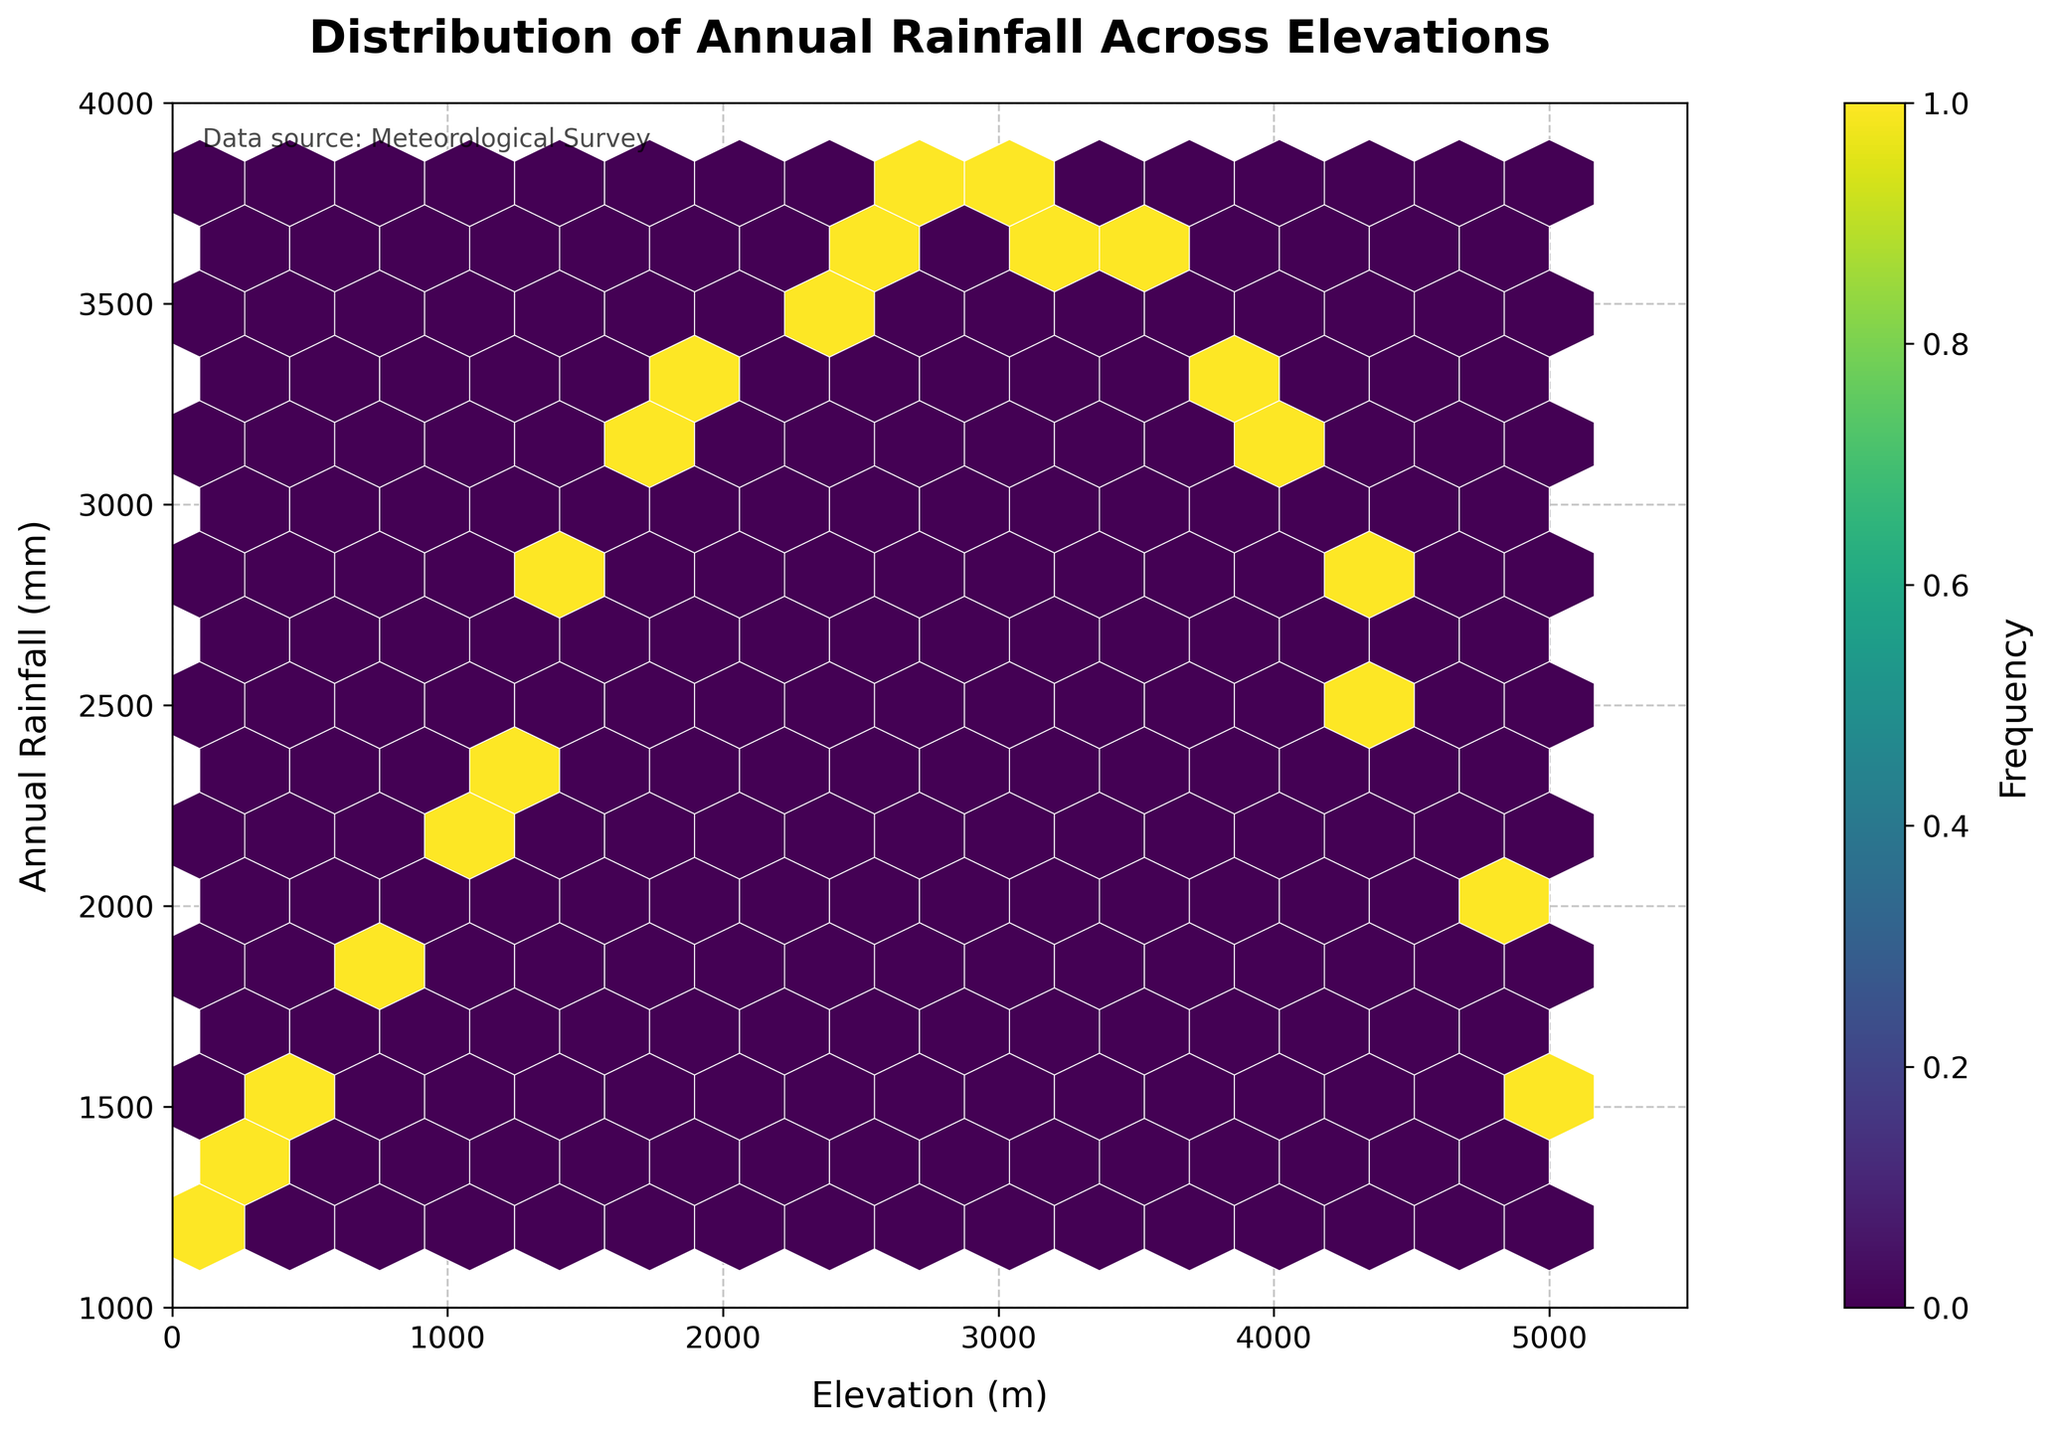What does the title of the hexbin plot indicate? The title of the hexbin plot is "Distribution of Annual Rainfall Across Elevations", which indicates that the plot shows how annual rainfall varies with elevation in a mountainous region.
Answer: Distribution of Annual Rainfall Across Elevations What is the range of elevations covered in the plot? The x-axis of the plot ranges from 0 to 5500 meters, indicating that the elevations covered in the plot are between 0 and 5500 meters.
Answer: 0 to 5500 meters Which frequency color is used to represent the highest density of data points? The plot uses the 'viridis' color map where brighter yellow represents the highest density of data points, as indicated by the color bar.
Answer: Brighter yellow What is the highest annual rainfall value depicted in the plot? The y-axis of the plot ranges up to 4000 mm, and the highest point in the plot is around 3800 mm, suggesting that 3800 mm is the highest annual rainfall value depicted.
Answer: 3800 mm Which elevation has the highest annual rainfall? By examining the plot, it can be seen that the highest annual rainfall (~3800 mm) occurs around an elevation of 3000 meters.
Answer: 3000 meters At around 3500 meters elevation, what is the approximate annual rainfall? Reviewing the data points around 3500 meters on the x-axis, the corresponding y-values show an annual rainfall of approximately 3550 mm.
Answer: 3550 mm Between what elevation ranges does the majority of the high rainfall occur? Observing the colored density in the plot, most high rainfall values are clustered around elevations between 1000 meters and 3750 meters.
Answer: 1000 to 3750 meters What trend can be inferred about the relationship between elevation and annual rainfall? From the pattern of the hexbin plot, it can be observed that annual rainfall generally increases with elevation up to around 3000 meters, then decreases at higher elevations.
Answer: Increases up to 3000m, then decreases Which section of the plot has the least density of data points? The sparse usage of lighter colors at lower and higher extremes of x and y axes implies that the sections with the least density are elevations below 1000 meters and above 4000 meters.
Answer: Below 1000m and above 4000m What does the color bar on the side of the plot represent? The color bar indicates the frequency of data points, with darker colors representing lower densities and brighter colors representing higher densities of rainfall measurements at specific elevations.
Answer: Frequency of data points 